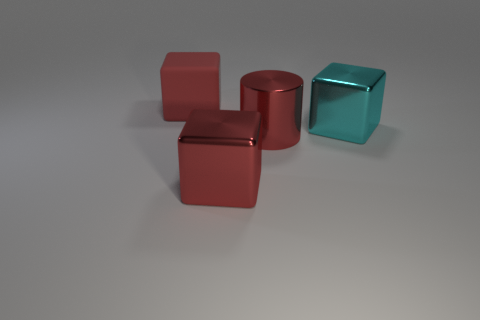Is the number of cylinders greater than the number of small metal cubes?
Make the answer very short. Yes. There is a big metal object left of the red cylinder; is there a big rubber block behind it?
Your answer should be compact. Yes. The other large shiny thing that is the same shape as the big cyan thing is what color?
Your response must be concise. Red. Are there any other things that have the same shape as the matte object?
Offer a terse response. Yes. The big cube that is made of the same material as the cyan thing is what color?
Provide a succinct answer. Red. Is there a cyan metallic object that is in front of the red object on the left side of the large red thing in front of the big shiny cylinder?
Ensure brevity in your answer.  Yes. Is the number of metal objects on the left side of the matte thing less than the number of red things on the right side of the red shiny cube?
Ensure brevity in your answer.  Yes. What number of big cylinders are made of the same material as the cyan block?
Keep it short and to the point. 1. Does the red metallic cylinder have the same size as the cube to the right of the red metal cylinder?
Make the answer very short. Yes. What is the material of the cylinder that is the same color as the large matte cube?
Offer a terse response. Metal. 